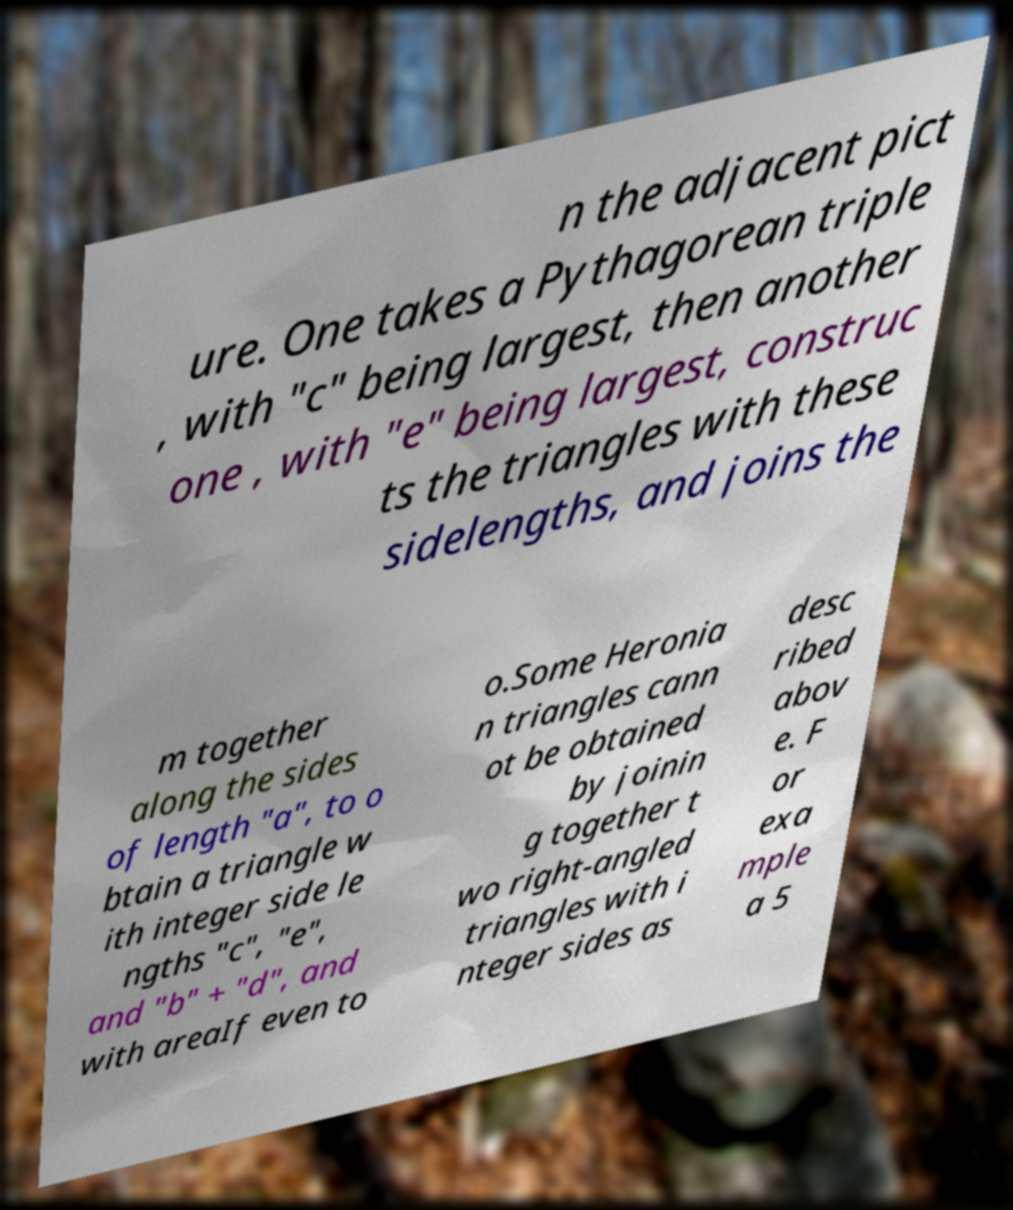Could you assist in decoding the text presented in this image and type it out clearly? n the adjacent pict ure. One takes a Pythagorean triple , with "c" being largest, then another one , with "e" being largest, construc ts the triangles with these sidelengths, and joins the m together along the sides of length "a", to o btain a triangle w ith integer side le ngths "c", "e", and "b" + "d", and with areaIf even to o.Some Heronia n triangles cann ot be obtained by joinin g together t wo right-angled triangles with i nteger sides as desc ribed abov e. F or exa mple a 5 